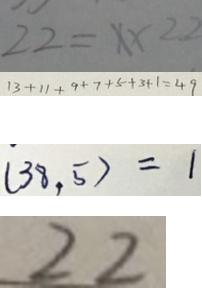Convert formula to latex. <formula><loc_0><loc_0><loc_500><loc_500>2 2 = x \times 2 2 
 1 3 + 1 1 + 9 + 7 + 5 + 3 + 1 = 4 9 
 ( 3 8 , 5 ) = 1 
 2 2</formula> 